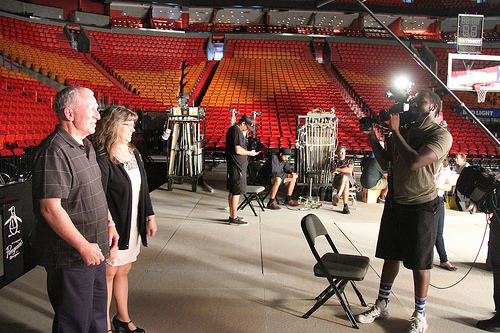<image>
Is the hoop in front of the camera? No. The hoop is not in front of the camera. The spatial positioning shows a different relationship between these objects. 